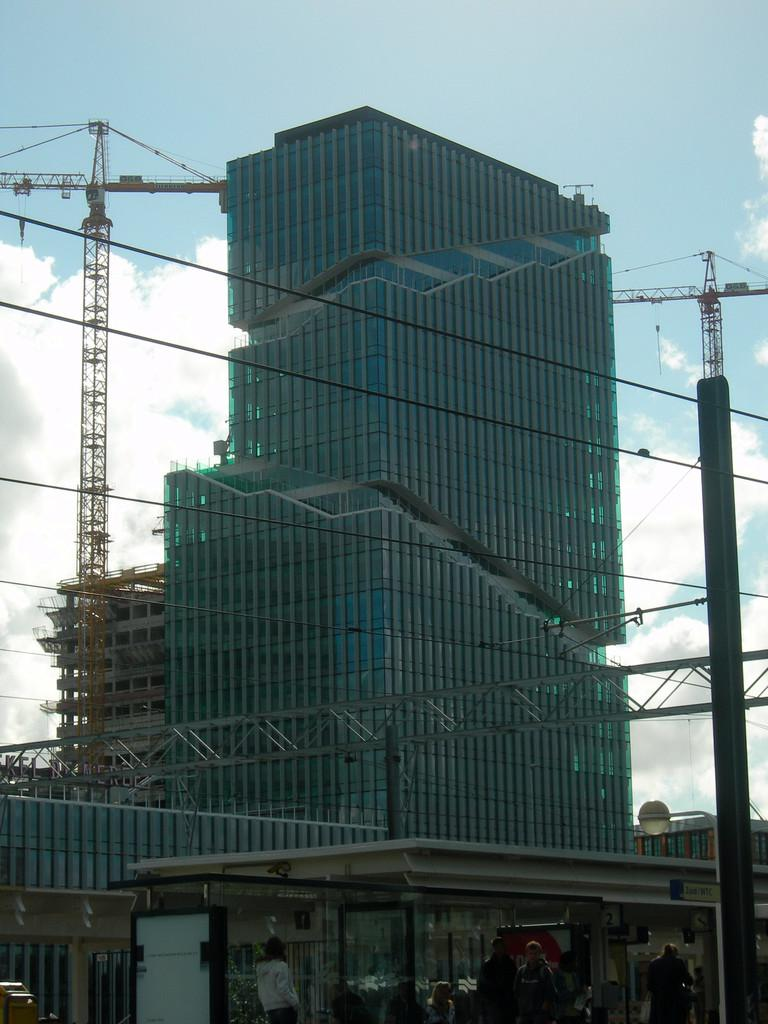What type of structure is present in the image? There is a building in the image. What is the large machine-like object in the image? There is a crane in the image. What can be seen in the background of the image? The sky is visible in the image, and there are clouds present. Can you describe the people in the image? There are people at the bottom of the image. What color is the goldfish swimming in the image? There is no goldfish present in the image. What type of clothing is the person wearing at the bottom of the image? The provided facts do not mention any specific clothing, so we cannot determine the type of clothing the people are wearing. 